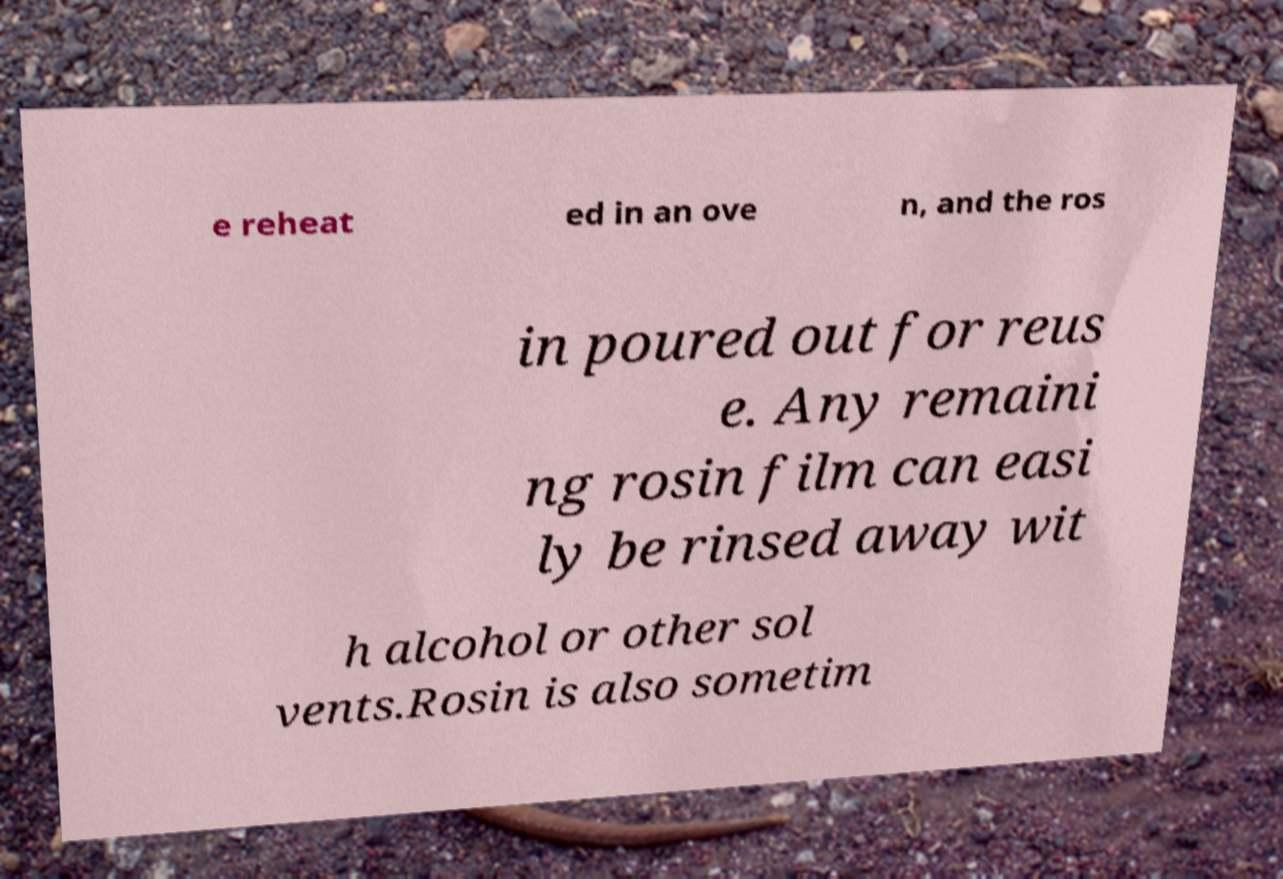Can you read and provide the text displayed in the image?This photo seems to have some interesting text. Can you extract and type it out for me? e reheat ed in an ove n, and the ros in poured out for reus e. Any remaini ng rosin film can easi ly be rinsed away wit h alcohol or other sol vents.Rosin is also sometim 